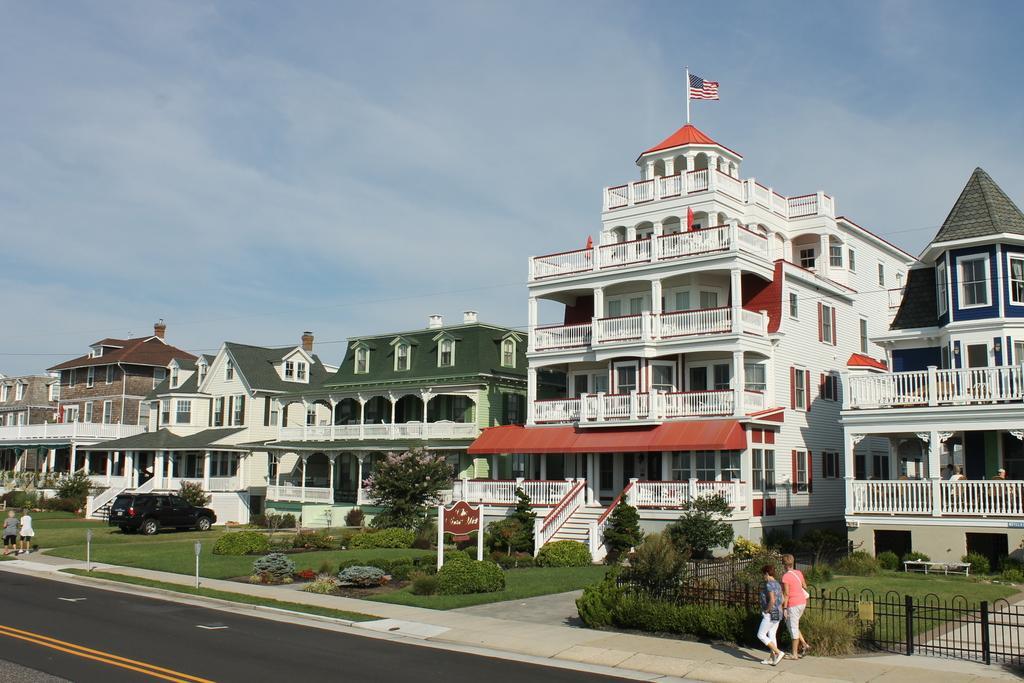Could you give a brief overview of what you see in this image? In this image in front there is a road. There are street lights, plants. There is a metal fence. There is a car. There are stairs. There are people walking on the pavement. In the background of the image there are buildings, trees and sky. At the bottom of the image there is grass on the surface. In the center of the image there is a flag. 